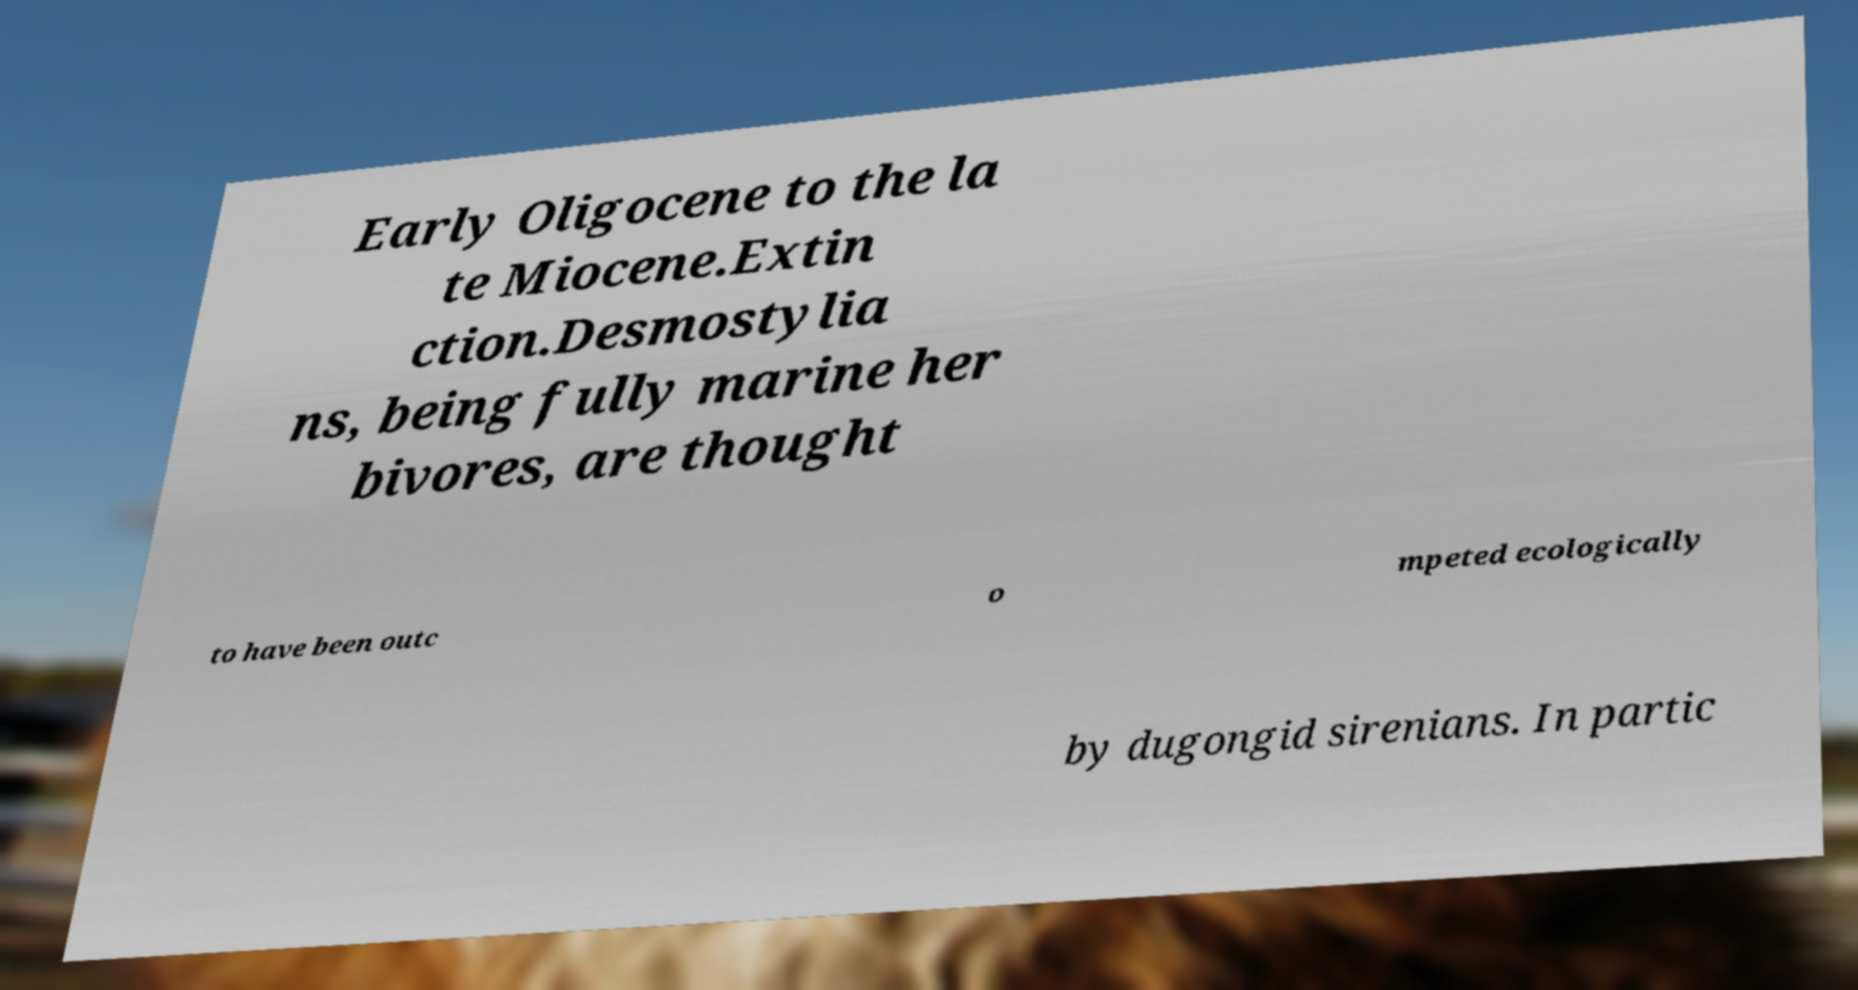Can you accurately transcribe the text from the provided image for me? Early Oligocene to the la te Miocene.Extin ction.Desmostylia ns, being fully marine her bivores, are thought to have been outc o mpeted ecologically by dugongid sirenians. In partic 